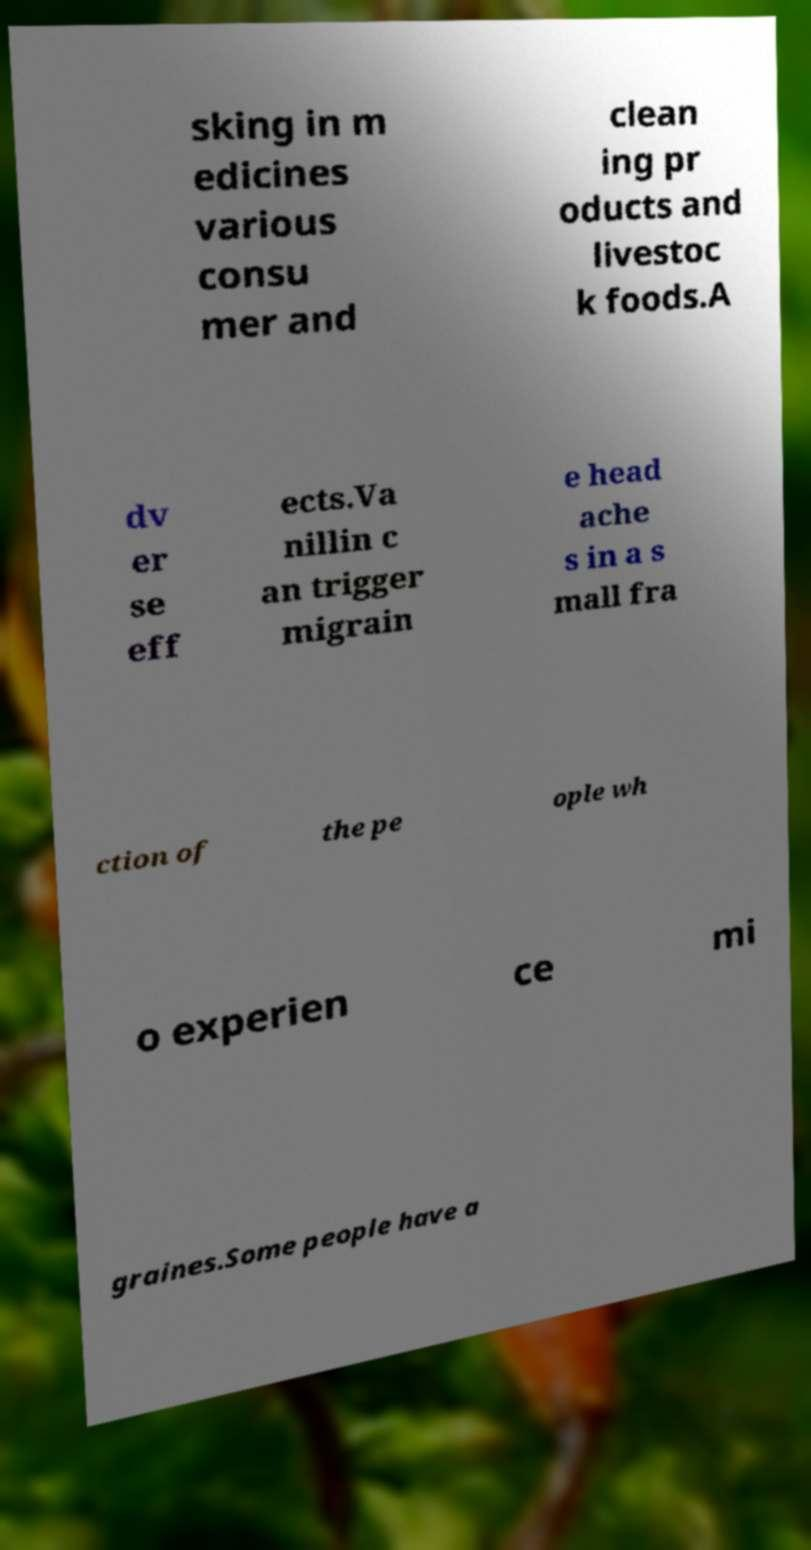Please identify and transcribe the text found in this image. sking in m edicines various consu mer and clean ing pr oducts and livestoc k foods.A dv er se eff ects.Va nillin c an trigger migrain e head ache s in a s mall fra ction of the pe ople wh o experien ce mi graines.Some people have a 